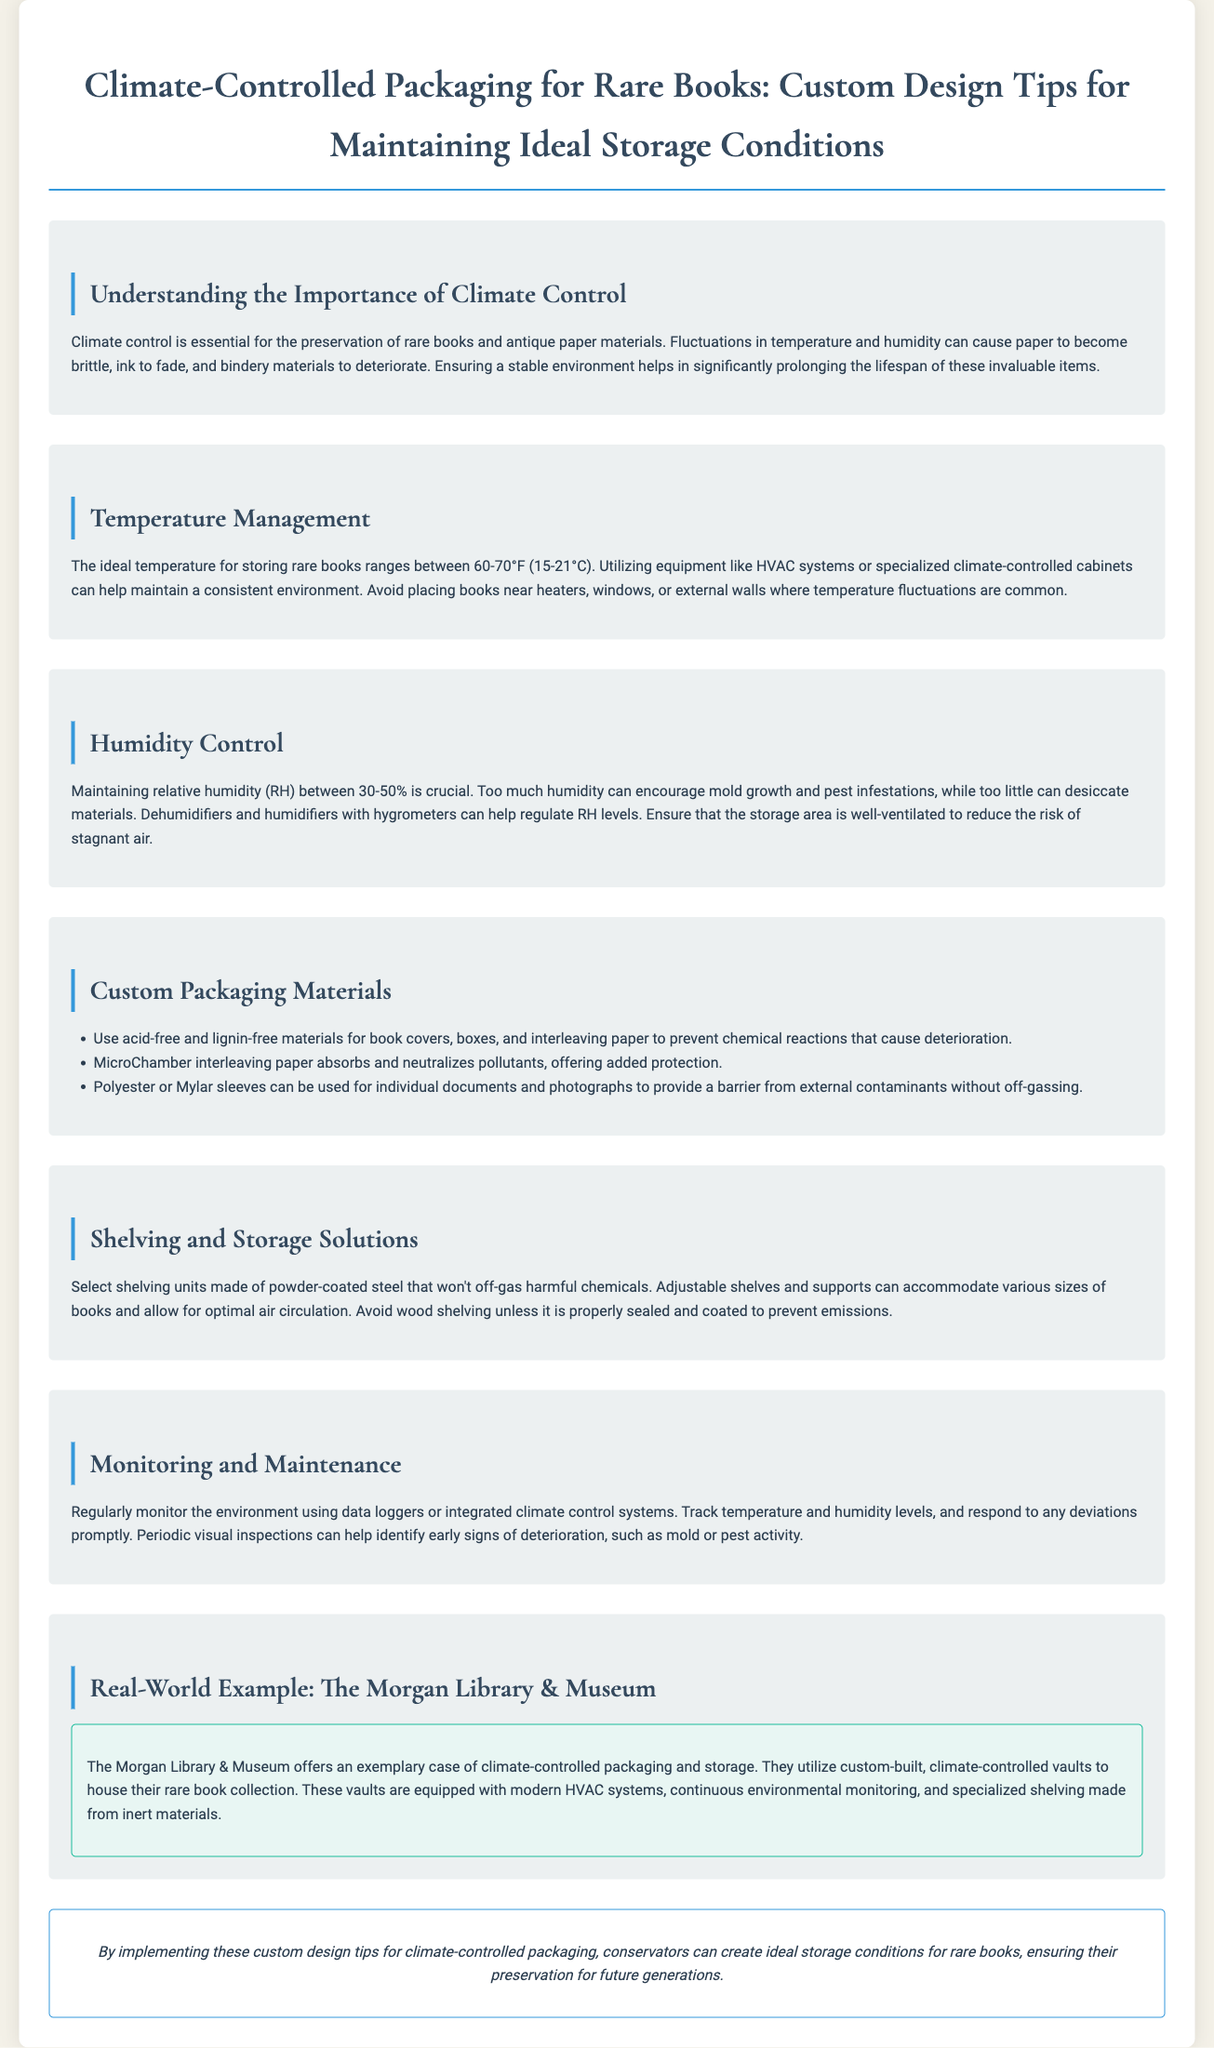What is the ideal temperature range for storing rare books? The document states that the ideal temperature for storing rare books ranges between 60-70°F (15-21°C).
Answer: 60-70°F (15-21°C) What is the recommended humidity level for rare book storage? The document specifies that maintaining relative humidity (RH) between 30-50% is crucial.
Answer: 30-50% Which materials should be used for book covers and boxes? It is recommended to use acid-free and lignin-free materials for book covers and boxes to prevent deterioration.
Answer: Acid-free and lignin-free materials What equipment can help maintain consistent temperature? The document mentions utilizing HVAC systems or specialized climate-controlled cabinets to maintain a consistent environment.
Answer: HVAC systems or specialized climate-controlled cabinets What type of shelving is recommended for storage? The document suggests selecting shelving units made of powder-coated steel that won't off-gas harmful chemicals.
Answer: Powder-coated steel What example illustrates effective climate-controlled packaging? The Morgan Library & Museum is provided as a real-world example of effective climate-controlled packaging and storage.
Answer: The Morgan Library & Museum What does MicroChamber interleaving paper do? MicroChamber interleaving paper absorbs and neutralizes pollutants, offering added protection.
Answer: Absorbs and neutralizes pollutants How can regular monitoring be achieved? The document suggests using data loggers or integrated climate control systems to regularly monitor conditions.
Answer: Data loggers or integrated climate control systems 